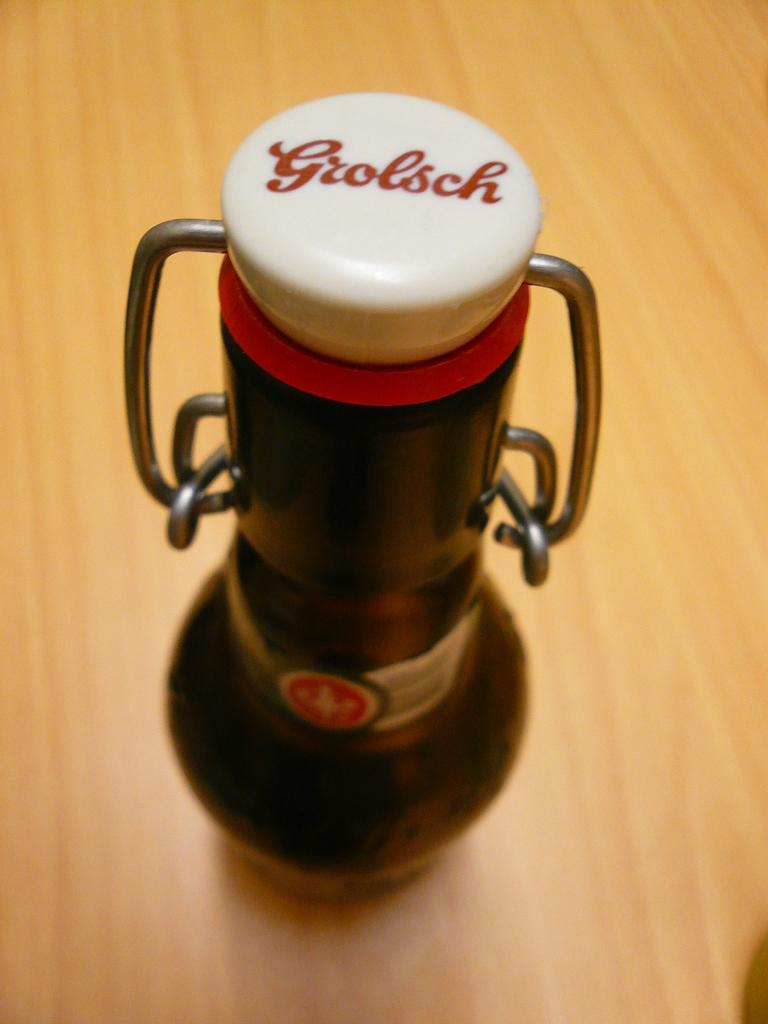<image>
Share a concise interpretation of the image provided. An odd shaped bottle with a lid that says Grolsch. 